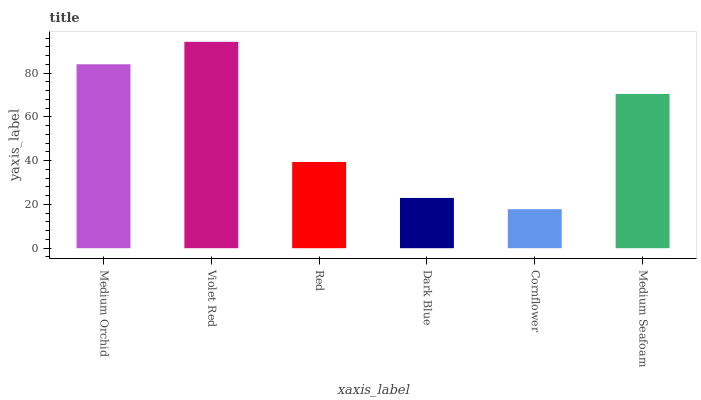Is Cornflower the minimum?
Answer yes or no. Yes. Is Violet Red the maximum?
Answer yes or no. Yes. Is Red the minimum?
Answer yes or no. No. Is Red the maximum?
Answer yes or no. No. Is Violet Red greater than Red?
Answer yes or no. Yes. Is Red less than Violet Red?
Answer yes or no. Yes. Is Red greater than Violet Red?
Answer yes or no. No. Is Violet Red less than Red?
Answer yes or no. No. Is Medium Seafoam the high median?
Answer yes or no. Yes. Is Red the low median?
Answer yes or no. Yes. Is Medium Orchid the high median?
Answer yes or no. No. Is Medium Orchid the low median?
Answer yes or no. No. 